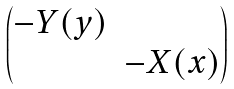Convert formula to latex. <formula><loc_0><loc_0><loc_500><loc_500>\begin{pmatrix} - Y ( y ) & \\ & - X ( x ) \end{pmatrix}</formula> 